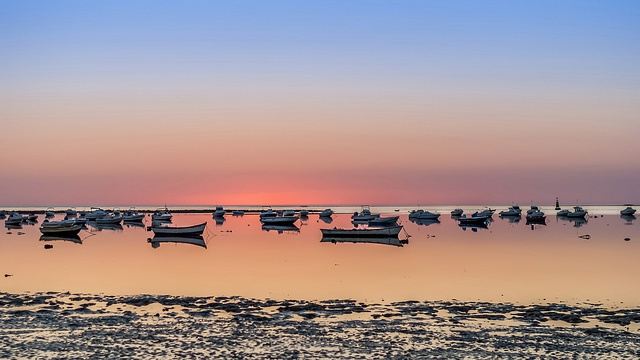Describe the objects in this image and their specific colors. I can see boat in lightblue, black, gray, tan, and darkgray tones, boat in lightblue, black, gray, and darkblue tones, boat in lightblue, black, gray, and darkblue tones, boat in lightblue, black, and gray tones, and boat in lightblue, black, gray, and darkblue tones in this image. 